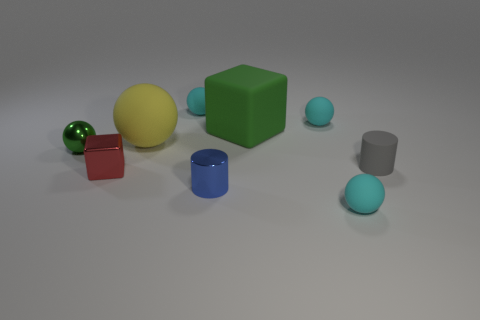Subtract all green cylinders. How many cyan spheres are left? 3 Subtract all green balls. How many balls are left? 4 Subtract all brown balls. Subtract all cyan cubes. How many balls are left? 5 Subtract all blocks. How many objects are left? 7 Subtract all gray cylinders. Subtract all metal cubes. How many objects are left? 7 Add 9 big green things. How many big green things are left? 10 Add 1 large blue metallic spheres. How many large blue metallic spheres exist? 1 Subtract 1 gray cylinders. How many objects are left? 8 